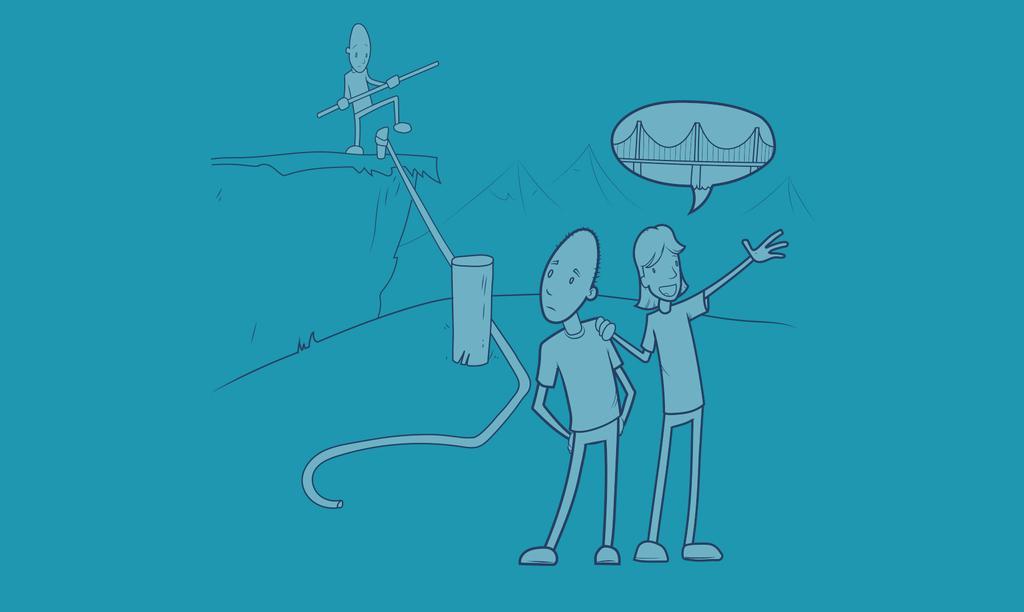In one or two sentences, can you explain what this image depicts? This is an animated image. 2 people are standing in the front. The person standing on the right is thinking of a bridge. There is another person at the back, holding a stick. There are mountains at the back and the background is blue. 